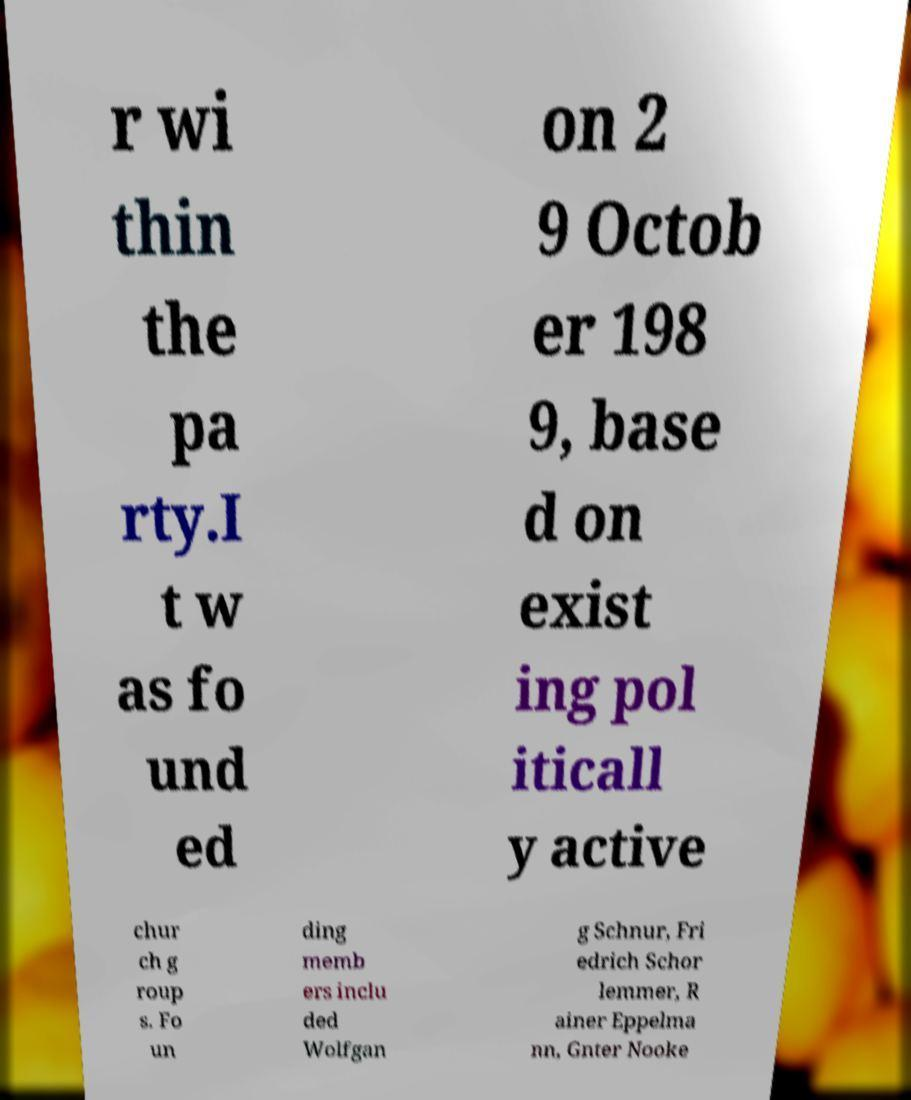I need the written content from this picture converted into text. Can you do that? r wi thin the pa rty.I t w as fo und ed on 2 9 Octob er 198 9, base d on exist ing pol iticall y active chur ch g roup s. Fo un ding memb ers inclu ded Wolfgan g Schnur, Fri edrich Schor lemmer, R ainer Eppelma nn, Gnter Nooke 